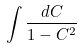<formula> <loc_0><loc_0><loc_500><loc_500>\int \frac { d C } { 1 - C ^ { 2 } }</formula> 